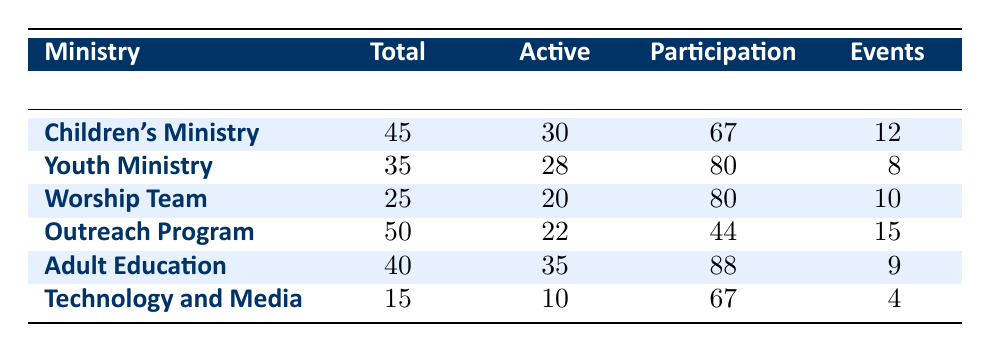What is the participation rate of the Children's Ministry? The participation rate for the Children's Ministry is directly provided in the table under the "Participation Rate" column. The value is listed as 67%.
Answer: 67% How many active volunteers are there in the Youth Ministry? The number of active volunteers in the Youth Ministry is found under the "Active Volunteers" column for that ministry. The value shown is 28.
Answer: 28 Which ministry has the highest participation rate? To find the highest participation rate, I compare the values in the "Participation Rate" column. The highest value is 88% for the Adult Education ministry.
Answer: Adult Education What is the total number of volunteers across all ministries? I need to sum the "Total Volunteers" from each ministry: 45 (Children's Ministry) + 35 (Youth Ministry) + 25 (Worship Team) + 50 (Outreach Program) + 40 (Adult Education) + 15 (Technology and Media) = 200.
Answer: 200 Is the participation rate for the Technology and Media ministry above or below average? First, I calculate the average participation rate of all ministries: (67 + 80 + 80 + 44 + 88 + 67) / 6 = 62.67%. The Technology and Media's participation rate of 67% is above this average.
Answer: Yes What is the difference in the number of active volunteers between the Adult Education and the Outreach Program? I subtract the number of active volunteers in Outreach Program (22) from Adult Education (35): 35 - 22 = 13.
Answer: 13 How many events were organized in total by all ministries? To find the total number of events organized, I sum the "Events Organized" column: 12 + 8 + 10 + 15 + 9 + 4 = 58.
Answer: 58 Is the number of total volunteers in the Worship Team greater than that in Technology and Media? By comparing the "Total Volunteers" values, the Worship Team has 25 volunteers and Technology and Media has 15. Therefore, 25 is greater than 15.
Answer: Yes What is the ratio of active volunteers to total volunteers in the Outreach Program? I divide the number of active volunteers (22) by the total volunteers (50): 22 / 50 simplifies to 0.44 or 44%.
Answer: 44% 